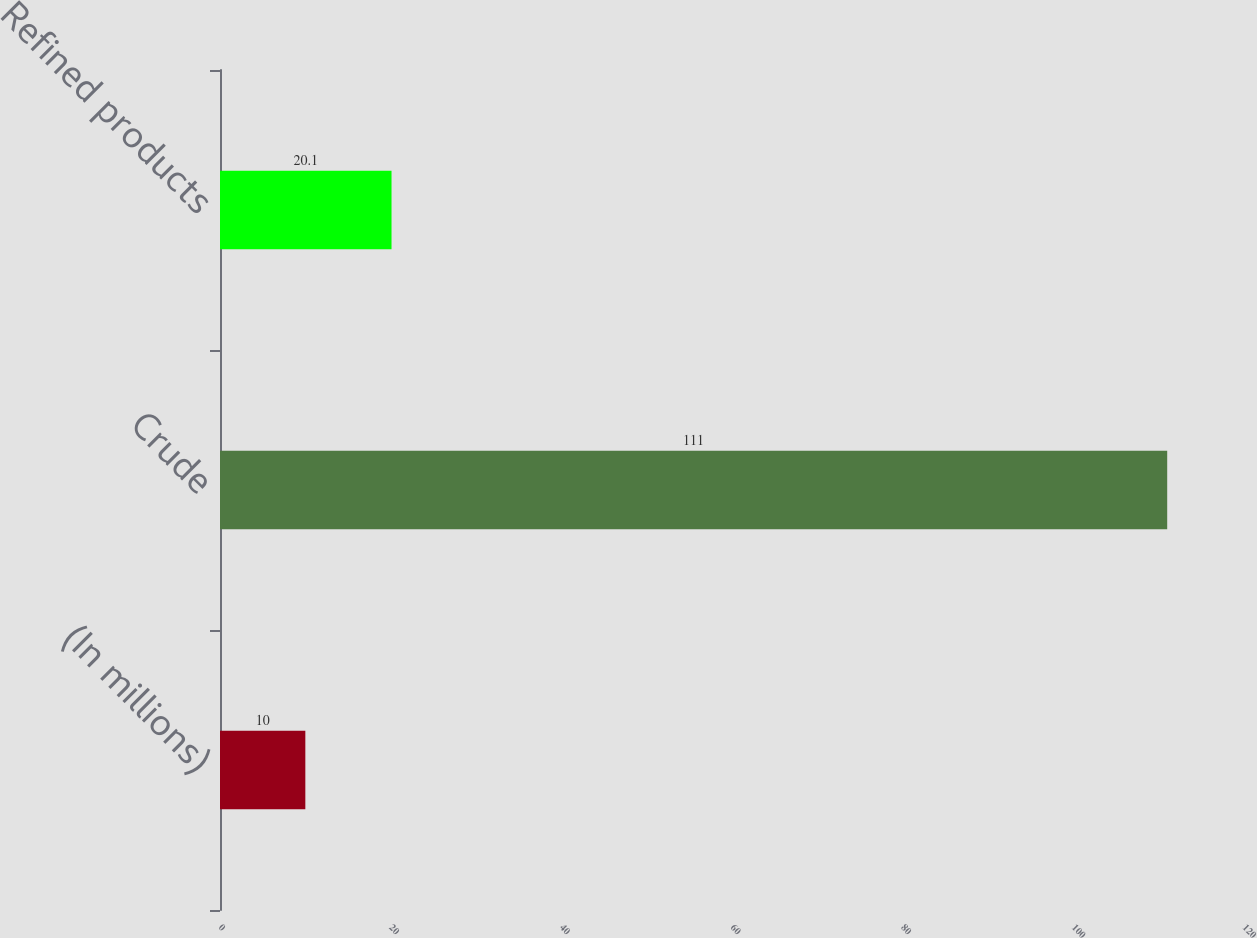<chart> <loc_0><loc_0><loc_500><loc_500><bar_chart><fcel>(In millions)<fcel>Crude<fcel>Refined products<nl><fcel>10<fcel>111<fcel>20.1<nl></chart> 